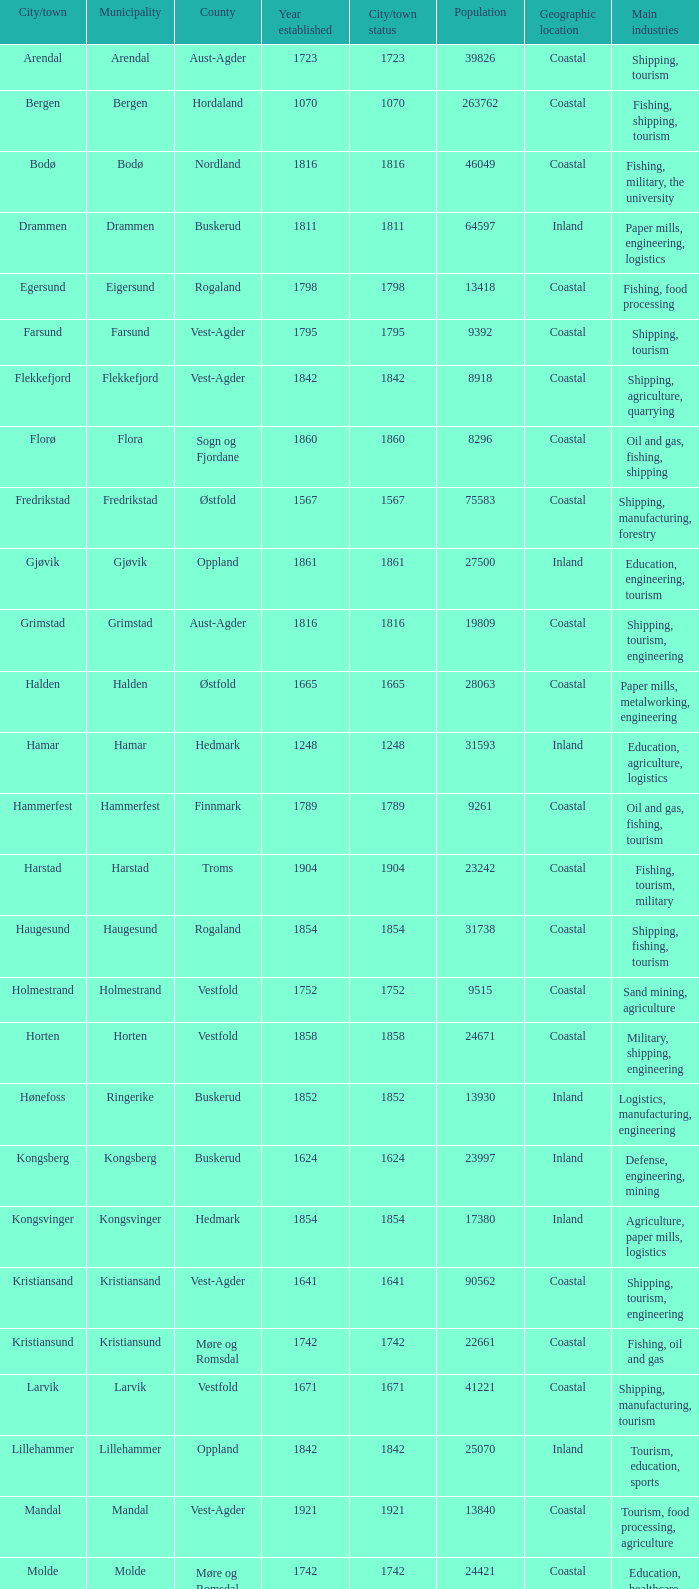What are the cities/towns located in the municipality of Horten? Horten. 